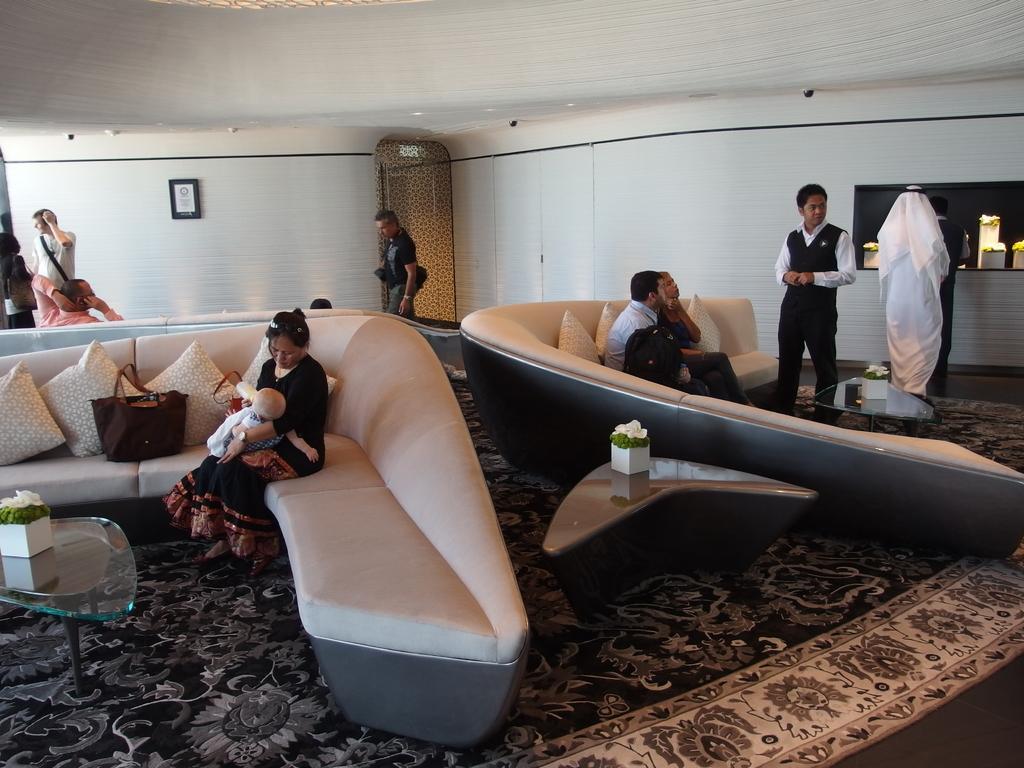Could you give a brief overview of what you see in this image? In this Image I see few people in which few of them are sitting and rest of them are standing. I see 2 tables on which there are plants and over here I see a bag on the couch and this woman is holding a baby in her hands. In the background I see the wall and the ceiling. 